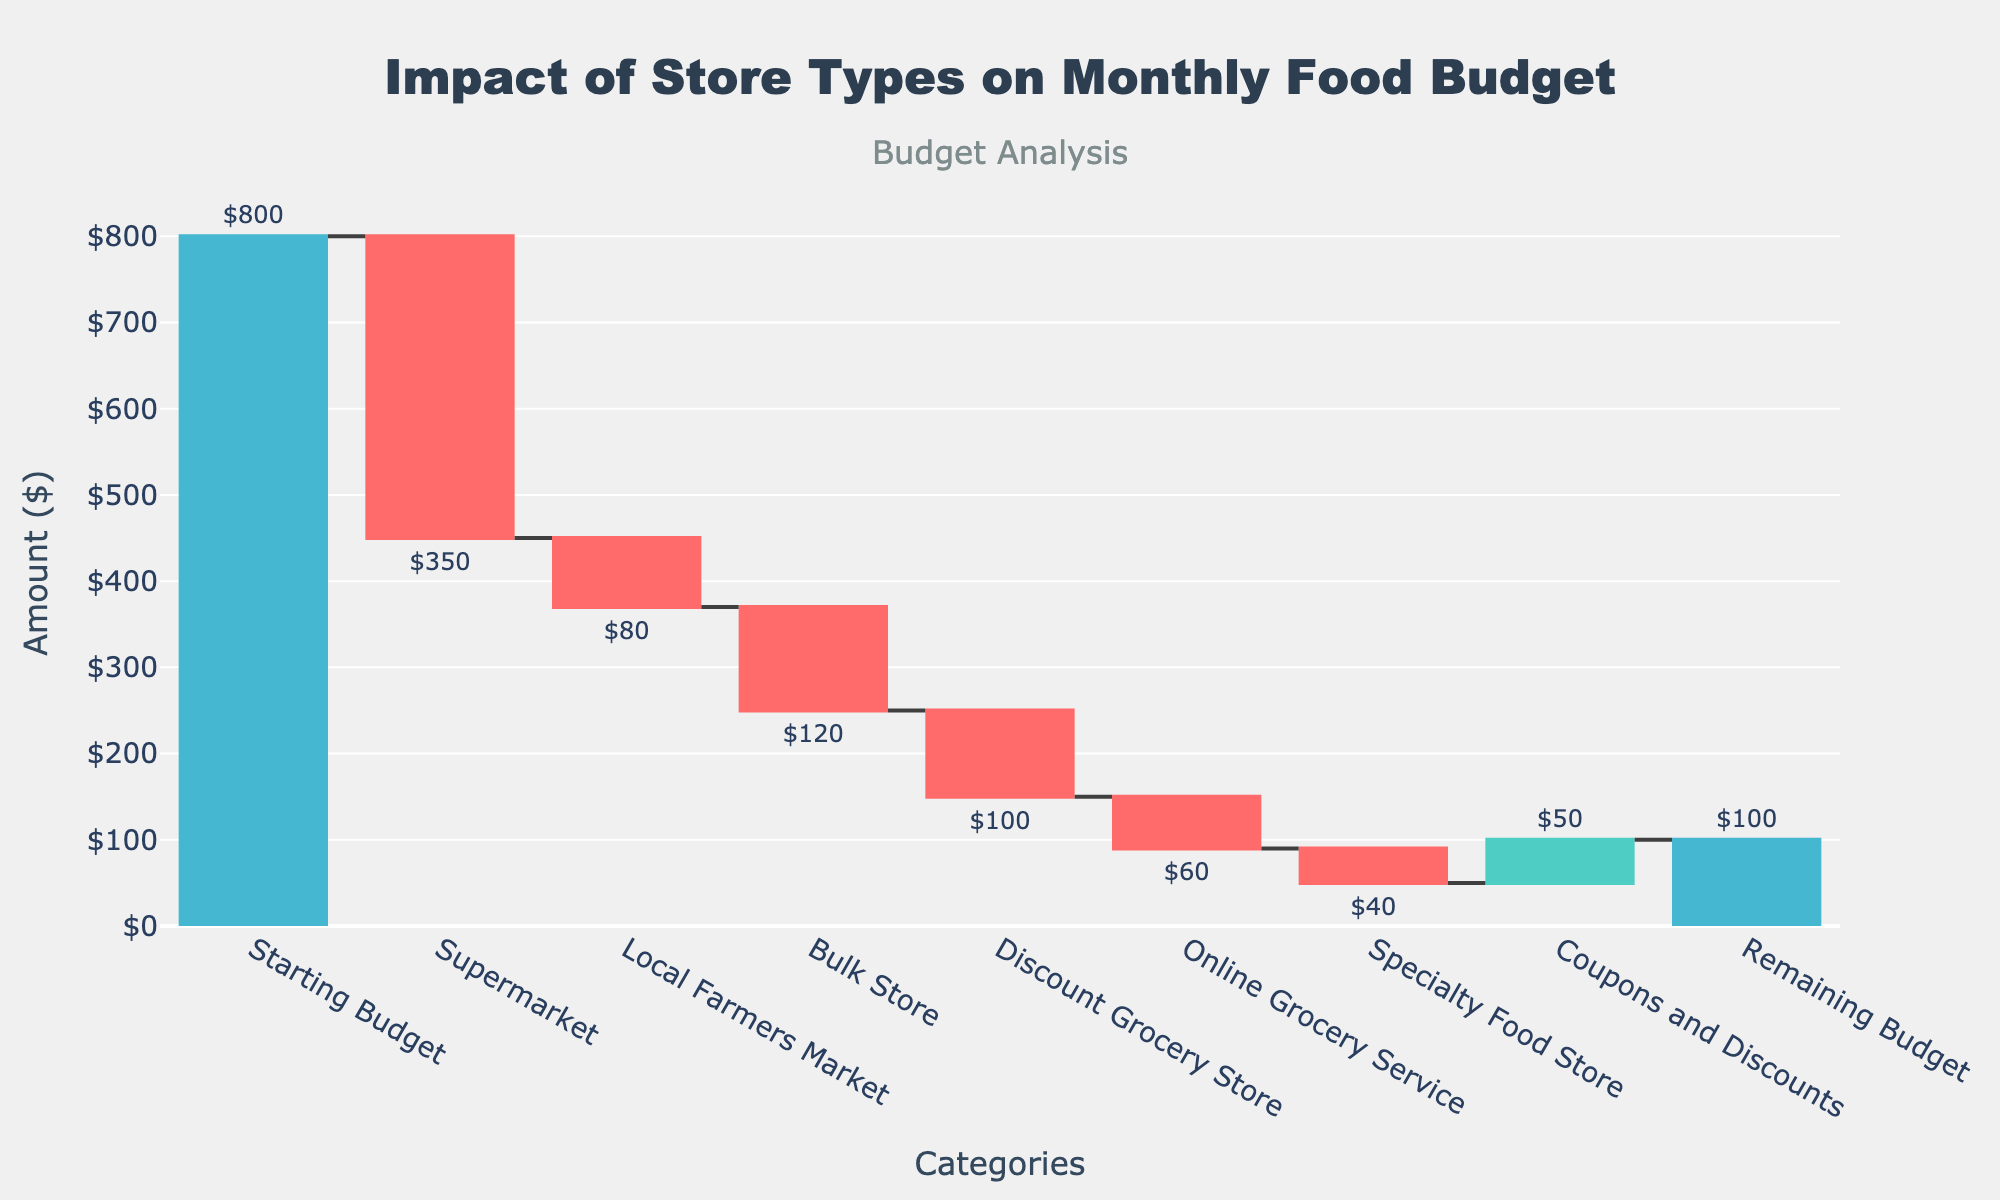What is the title of the chart? The title of the chart can be found at the top and it reads: "Impact of Store Types on Monthly Food Budget".
Answer: Impact of Store Types on Monthly Food Budget How much is spent at the Supermarket? Look for the bar labeled "Supermarket" and observe the text value above or beside it. The amount is shown as $350.
Answer: $350 What is the total initial budget? The first bar labeled "Starting Budget" shows the initial budget amount, which is $800.
Answer: $800 What is the net effect of Coupons and Discounts? Look for the bar labeled "Coupons and Discounts", which shows a positive value of $50. This indicates a reduction in the total spending.
Answer: $50 How much remains in the budget by the end of the month? The last bar labeled "Remaining Budget" shows the amount left, which is $100.
Answer: $100 How much more is spent at the Supermarket compared to the Local Farmers Market? The amount spent at the Supermarket is $350 and at the Local Farmers Market is $80. Subtract $80 from $350 to find the difference ($350 - $80 = $270).
Answer: $270 What is the total amount spent across all store types (excluding Coupons and Discounts)? Sum all negative values representing spending at different store types: $350 (Supermarket) + $80 (Local Farmers Market) + $120 (Bulk Store) + $100 (Discount Grocery Store) + $60 (Online Grocery Service) + $40 (Specialty Food Store) = $750.
Answer: $750 Which store type contributes the least in spending to the monthly food budget? Examine the bars representing spending amounts. The "Specialty Food Store" bar shows the smallest amount, which is $40.
Answer: Specialty Food Store If there were no Coupons and Discounts, what would the remaining budget be? The current remaining budget is $100. Adding the $50 saved from Coupons and Discounts back to the total spending gives $100 - $50 = $50. Thus, the remaining budget would be $50.
Answer: $50 By how much does the bulk shopping reduce the overall budget compared to the Specialty Food Store? The spending at the Bulk Store is $120 and at the Specialty Food Store is $40. Subtract $40 from $120 to find the difference ($120 - $40 = $80).
Answer: $80 